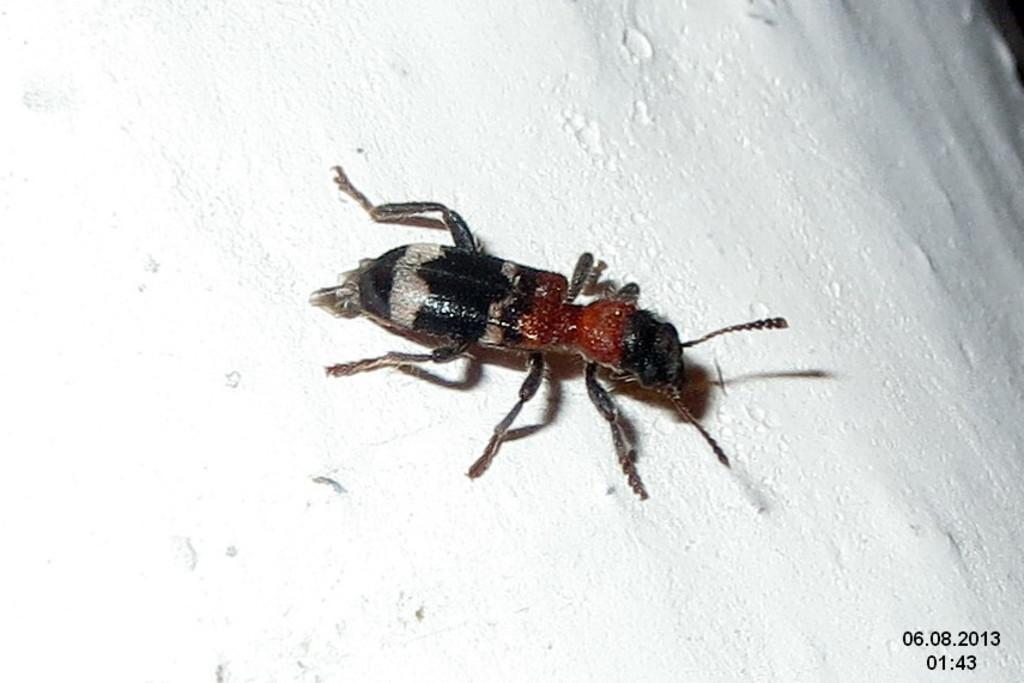Could you give a brief overview of what you see in this image? In the picture we can see a wall and on it we can see an insect which is white and black in color with legs and antenna. 